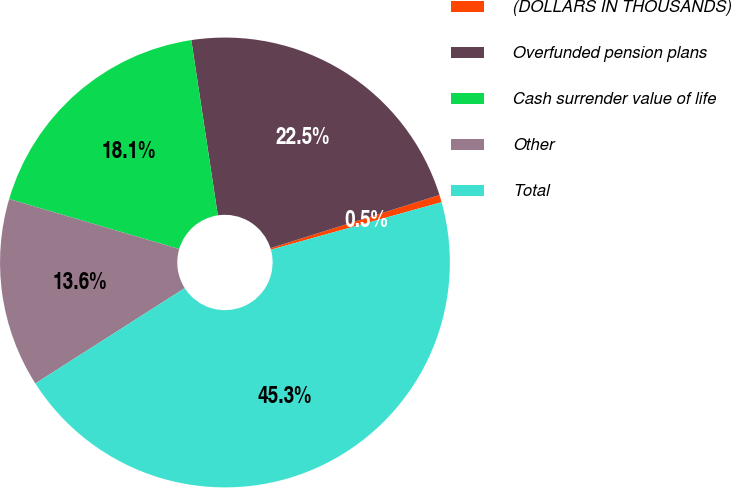<chart> <loc_0><loc_0><loc_500><loc_500><pie_chart><fcel>(DOLLARS IN THOUSANDS)<fcel>Overfunded pension plans<fcel>Cash surrender value of life<fcel>Other<fcel>Total<nl><fcel>0.53%<fcel>22.54%<fcel>18.06%<fcel>13.59%<fcel>45.28%<nl></chart> 